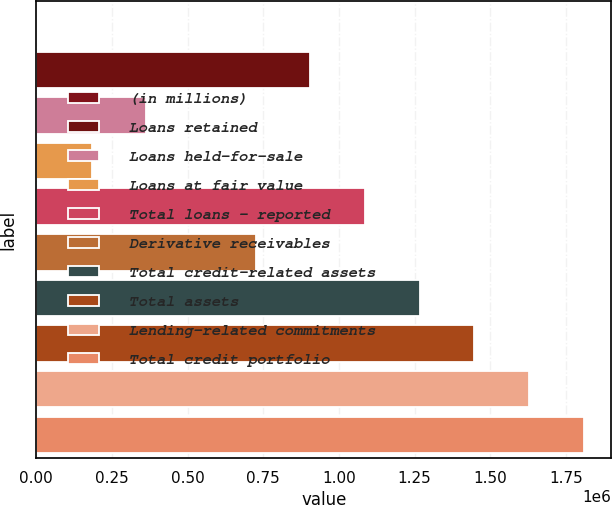<chart> <loc_0><loc_0><loc_500><loc_500><bar_chart><fcel>(in millions)<fcel>Loans retained<fcel>Loans held-for-sale<fcel>Loans at fair value<fcel>Total loans - reported<fcel>Derivative receivables<fcel>Total credit-related assets<fcel>Total assets<fcel>Lending-related commitments<fcel>Total credit portfolio<nl><fcel>2011<fcel>905716<fcel>363493<fcel>182752<fcel>1.08646e+06<fcel>724975<fcel>1.2672e+06<fcel>1.44794e+06<fcel>1.62868e+06<fcel>1.80942e+06<nl></chart> 